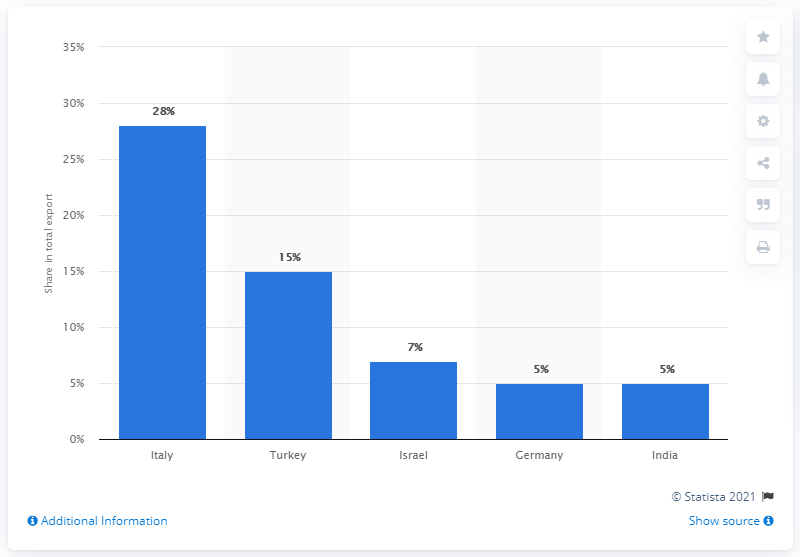Give some essential details in this illustration. In 2017, Turkey was the main export partner of Germany, accounting for 7.1% of Germany's total exports, while Germany was the main export partner of Turkey, accounting for 10.8% of Turkey's total exports. The lowest value of main export partners in 2017 was India. In 2017, Italy was the most important export partner of Azerbaijan. 